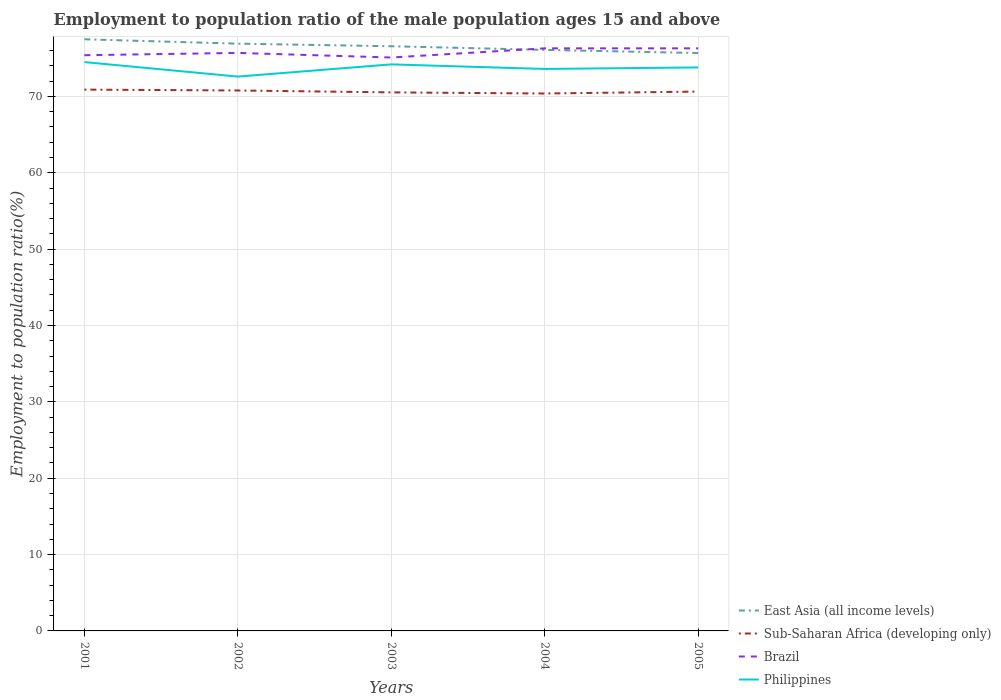Across all years, what is the maximum employment to population ratio in East Asia (all income levels)?
Your answer should be very brief. 75.69. What is the total employment to population ratio in Brazil in the graph?
Your answer should be very brief. -0.9. What is the difference between the highest and the second highest employment to population ratio in Philippines?
Provide a succinct answer. 1.9. Is the employment to population ratio in Sub-Saharan Africa (developing only) strictly greater than the employment to population ratio in Brazil over the years?
Your answer should be compact. Yes. Are the values on the major ticks of Y-axis written in scientific E-notation?
Your answer should be very brief. No. Does the graph contain any zero values?
Provide a succinct answer. No. Does the graph contain grids?
Ensure brevity in your answer.  Yes. What is the title of the graph?
Your answer should be very brief. Employment to population ratio of the male population ages 15 and above. What is the label or title of the Y-axis?
Your response must be concise. Employment to population ratio(%). What is the Employment to population ratio(%) of East Asia (all income levels) in 2001?
Provide a succinct answer. 77.49. What is the Employment to population ratio(%) in Sub-Saharan Africa (developing only) in 2001?
Provide a succinct answer. 70.89. What is the Employment to population ratio(%) in Brazil in 2001?
Provide a succinct answer. 75.4. What is the Employment to population ratio(%) in Philippines in 2001?
Provide a short and direct response. 74.5. What is the Employment to population ratio(%) in East Asia (all income levels) in 2002?
Make the answer very short. 76.91. What is the Employment to population ratio(%) of Sub-Saharan Africa (developing only) in 2002?
Provide a succinct answer. 70.78. What is the Employment to population ratio(%) in Brazil in 2002?
Your answer should be compact. 75.7. What is the Employment to population ratio(%) of Philippines in 2002?
Offer a very short reply. 72.6. What is the Employment to population ratio(%) in East Asia (all income levels) in 2003?
Provide a succinct answer. 76.58. What is the Employment to population ratio(%) in Sub-Saharan Africa (developing only) in 2003?
Provide a succinct answer. 70.53. What is the Employment to population ratio(%) of Brazil in 2003?
Provide a succinct answer. 75.1. What is the Employment to population ratio(%) of Philippines in 2003?
Keep it short and to the point. 74.2. What is the Employment to population ratio(%) in East Asia (all income levels) in 2004?
Offer a terse response. 76.1. What is the Employment to population ratio(%) of Sub-Saharan Africa (developing only) in 2004?
Ensure brevity in your answer.  70.38. What is the Employment to population ratio(%) of Brazil in 2004?
Offer a terse response. 76.3. What is the Employment to population ratio(%) of Philippines in 2004?
Offer a terse response. 73.6. What is the Employment to population ratio(%) in East Asia (all income levels) in 2005?
Keep it short and to the point. 75.69. What is the Employment to population ratio(%) of Sub-Saharan Africa (developing only) in 2005?
Give a very brief answer. 70.64. What is the Employment to population ratio(%) in Brazil in 2005?
Your answer should be compact. 76.3. What is the Employment to population ratio(%) in Philippines in 2005?
Provide a short and direct response. 73.8. Across all years, what is the maximum Employment to population ratio(%) of East Asia (all income levels)?
Ensure brevity in your answer.  77.49. Across all years, what is the maximum Employment to population ratio(%) in Sub-Saharan Africa (developing only)?
Provide a short and direct response. 70.89. Across all years, what is the maximum Employment to population ratio(%) in Brazil?
Offer a very short reply. 76.3. Across all years, what is the maximum Employment to population ratio(%) in Philippines?
Provide a short and direct response. 74.5. Across all years, what is the minimum Employment to population ratio(%) of East Asia (all income levels)?
Provide a succinct answer. 75.69. Across all years, what is the minimum Employment to population ratio(%) in Sub-Saharan Africa (developing only)?
Offer a very short reply. 70.38. Across all years, what is the minimum Employment to population ratio(%) of Brazil?
Make the answer very short. 75.1. Across all years, what is the minimum Employment to population ratio(%) of Philippines?
Make the answer very short. 72.6. What is the total Employment to population ratio(%) in East Asia (all income levels) in the graph?
Give a very brief answer. 382.76. What is the total Employment to population ratio(%) of Sub-Saharan Africa (developing only) in the graph?
Provide a succinct answer. 353.23. What is the total Employment to population ratio(%) in Brazil in the graph?
Provide a short and direct response. 378.8. What is the total Employment to population ratio(%) of Philippines in the graph?
Offer a terse response. 368.7. What is the difference between the Employment to population ratio(%) of East Asia (all income levels) in 2001 and that in 2002?
Give a very brief answer. 0.57. What is the difference between the Employment to population ratio(%) of Sub-Saharan Africa (developing only) in 2001 and that in 2002?
Provide a succinct answer. 0.11. What is the difference between the Employment to population ratio(%) in East Asia (all income levels) in 2001 and that in 2003?
Your response must be concise. 0.91. What is the difference between the Employment to population ratio(%) in Sub-Saharan Africa (developing only) in 2001 and that in 2003?
Offer a very short reply. 0.36. What is the difference between the Employment to population ratio(%) in Brazil in 2001 and that in 2003?
Your answer should be very brief. 0.3. What is the difference between the Employment to population ratio(%) in East Asia (all income levels) in 2001 and that in 2004?
Offer a terse response. 1.39. What is the difference between the Employment to population ratio(%) of Sub-Saharan Africa (developing only) in 2001 and that in 2004?
Your answer should be very brief. 0.51. What is the difference between the Employment to population ratio(%) of Brazil in 2001 and that in 2004?
Keep it short and to the point. -0.9. What is the difference between the Employment to population ratio(%) in East Asia (all income levels) in 2001 and that in 2005?
Your answer should be compact. 1.8. What is the difference between the Employment to population ratio(%) in Sub-Saharan Africa (developing only) in 2001 and that in 2005?
Offer a very short reply. 0.26. What is the difference between the Employment to population ratio(%) in Philippines in 2001 and that in 2005?
Ensure brevity in your answer.  0.7. What is the difference between the Employment to population ratio(%) of East Asia (all income levels) in 2002 and that in 2003?
Ensure brevity in your answer.  0.34. What is the difference between the Employment to population ratio(%) in Sub-Saharan Africa (developing only) in 2002 and that in 2003?
Give a very brief answer. 0.25. What is the difference between the Employment to population ratio(%) of East Asia (all income levels) in 2002 and that in 2004?
Make the answer very short. 0.81. What is the difference between the Employment to population ratio(%) of Sub-Saharan Africa (developing only) in 2002 and that in 2004?
Give a very brief answer. 0.4. What is the difference between the Employment to population ratio(%) of Brazil in 2002 and that in 2004?
Offer a terse response. -0.6. What is the difference between the Employment to population ratio(%) in East Asia (all income levels) in 2002 and that in 2005?
Make the answer very short. 1.23. What is the difference between the Employment to population ratio(%) of Sub-Saharan Africa (developing only) in 2002 and that in 2005?
Give a very brief answer. 0.14. What is the difference between the Employment to population ratio(%) of Brazil in 2002 and that in 2005?
Offer a terse response. -0.6. What is the difference between the Employment to population ratio(%) of Philippines in 2002 and that in 2005?
Your answer should be compact. -1.2. What is the difference between the Employment to population ratio(%) of East Asia (all income levels) in 2003 and that in 2004?
Provide a short and direct response. 0.48. What is the difference between the Employment to population ratio(%) of Sub-Saharan Africa (developing only) in 2003 and that in 2004?
Offer a very short reply. 0.15. What is the difference between the Employment to population ratio(%) in Philippines in 2003 and that in 2004?
Your answer should be compact. 0.6. What is the difference between the Employment to population ratio(%) of East Asia (all income levels) in 2003 and that in 2005?
Your answer should be compact. 0.89. What is the difference between the Employment to population ratio(%) of Sub-Saharan Africa (developing only) in 2003 and that in 2005?
Provide a short and direct response. -0.1. What is the difference between the Employment to population ratio(%) of Philippines in 2003 and that in 2005?
Your answer should be very brief. 0.4. What is the difference between the Employment to population ratio(%) in East Asia (all income levels) in 2004 and that in 2005?
Offer a very short reply. 0.41. What is the difference between the Employment to population ratio(%) in Sub-Saharan Africa (developing only) in 2004 and that in 2005?
Offer a terse response. -0.25. What is the difference between the Employment to population ratio(%) of Brazil in 2004 and that in 2005?
Provide a succinct answer. 0. What is the difference between the Employment to population ratio(%) in East Asia (all income levels) in 2001 and the Employment to population ratio(%) in Sub-Saharan Africa (developing only) in 2002?
Your answer should be very brief. 6.7. What is the difference between the Employment to population ratio(%) in East Asia (all income levels) in 2001 and the Employment to population ratio(%) in Brazil in 2002?
Provide a succinct answer. 1.79. What is the difference between the Employment to population ratio(%) of East Asia (all income levels) in 2001 and the Employment to population ratio(%) of Philippines in 2002?
Provide a succinct answer. 4.89. What is the difference between the Employment to population ratio(%) of Sub-Saharan Africa (developing only) in 2001 and the Employment to population ratio(%) of Brazil in 2002?
Provide a succinct answer. -4.81. What is the difference between the Employment to population ratio(%) in Sub-Saharan Africa (developing only) in 2001 and the Employment to population ratio(%) in Philippines in 2002?
Make the answer very short. -1.71. What is the difference between the Employment to population ratio(%) of Brazil in 2001 and the Employment to population ratio(%) of Philippines in 2002?
Your answer should be very brief. 2.8. What is the difference between the Employment to population ratio(%) in East Asia (all income levels) in 2001 and the Employment to population ratio(%) in Sub-Saharan Africa (developing only) in 2003?
Your answer should be compact. 6.95. What is the difference between the Employment to population ratio(%) of East Asia (all income levels) in 2001 and the Employment to population ratio(%) of Brazil in 2003?
Your answer should be compact. 2.39. What is the difference between the Employment to population ratio(%) in East Asia (all income levels) in 2001 and the Employment to population ratio(%) in Philippines in 2003?
Provide a short and direct response. 3.29. What is the difference between the Employment to population ratio(%) of Sub-Saharan Africa (developing only) in 2001 and the Employment to population ratio(%) of Brazil in 2003?
Provide a succinct answer. -4.21. What is the difference between the Employment to population ratio(%) of Sub-Saharan Africa (developing only) in 2001 and the Employment to population ratio(%) of Philippines in 2003?
Offer a very short reply. -3.31. What is the difference between the Employment to population ratio(%) in Brazil in 2001 and the Employment to population ratio(%) in Philippines in 2003?
Make the answer very short. 1.2. What is the difference between the Employment to population ratio(%) in East Asia (all income levels) in 2001 and the Employment to population ratio(%) in Sub-Saharan Africa (developing only) in 2004?
Offer a terse response. 7.1. What is the difference between the Employment to population ratio(%) of East Asia (all income levels) in 2001 and the Employment to population ratio(%) of Brazil in 2004?
Make the answer very short. 1.19. What is the difference between the Employment to population ratio(%) of East Asia (all income levels) in 2001 and the Employment to population ratio(%) of Philippines in 2004?
Make the answer very short. 3.89. What is the difference between the Employment to population ratio(%) of Sub-Saharan Africa (developing only) in 2001 and the Employment to population ratio(%) of Brazil in 2004?
Offer a very short reply. -5.41. What is the difference between the Employment to population ratio(%) in Sub-Saharan Africa (developing only) in 2001 and the Employment to population ratio(%) in Philippines in 2004?
Offer a very short reply. -2.71. What is the difference between the Employment to population ratio(%) in Brazil in 2001 and the Employment to population ratio(%) in Philippines in 2004?
Provide a short and direct response. 1.8. What is the difference between the Employment to population ratio(%) in East Asia (all income levels) in 2001 and the Employment to population ratio(%) in Sub-Saharan Africa (developing only) in 2005?
Keep it short and to the point. 6.85. What is the difference between the Employment to population ratio(%) in East Asia (all income levels) in 2001 and the Employment to population ratio(%) in Brazil in 2005?
Ensure brevity in your answer.  1.19. What is the difference between the Employment to population ratio(%) in East Asia (all income levels) in 2001 and the Employment to population ratio(%) in Philippines in 2005?
Your response must be concise. 3.69. What is the difference between the Employment to population ratio(%) in Sub-Saharan Africa (developing only) in 2001 and the Employment to population ratio(%) in Brazil in 2005?
Offer a terse response. -5.41. What is the difference between the Employment to population ratio(%) of Sub-Saharan Africa (developing only) in 2001 and the Employment to population ratio(%) of Philippines in 2005?
Ensure brevity in your answer.  -2.91. What is the difference between the Employment to population ratio(%) of East Asia (all income levels) in 2002 and the Employment to population ratio(%) of Sub-Saharan Africa (developing only) in 2003?
Make the answer very short. 6.38. What is the difference between the Employment to population ratio(%) of East Asia (all income levels) in 2002 and the Employment to population ratio(%) of Brazil in 2003?
Ensure brevity in your answer.  1.81. What is the difference between the Employment to population ratio(%) in East Asia (all income levels) in 2002 and the Employment to population ratio(%) in Philippines in 2003?
Offer a terse response. 2.71. What is the difference between the Employment to population ratio(%) of Sub-Saharan Africa (developing only) in 2002 and the Employment to population ratio(%) of Brazil in 2003?
Provide a succinct answer. -4.32. What is the difference between the Employment to population ratio(%) of Sub-Saharan Africa (developing only) in 2002 and the Employment to population ratio(%) of Philippines in 2003?
Offer a terse response. -3.42. What is the difference between the Employment to population ratio(%) in East Asia (all income levels) in 2002 and the Employment to population ratio(%) in Sub-Saharan Africa (developing only) in 2004?
Your answer should be compact. 6.53. What is the difference between the Employment to population ratio(%) of East Asia (all income levels) in 2002 and the Employment to population ratio(%) of Brazil in 2004?
Give a very brief answer. 0.61. What is the difference between the Employment to population ratio(%) in East Asia (all income levels) in 2002 and the Employment to population ratio(%) in Philippines in 2004?
Offer a very short reply. 3.31. What is the difference between the Employment to population ratio(%) of Sub-Saharan Africa (developing only) in 2002 and the Employment to population ratio(%) of Brazil in 2004?
Give a very brief answer. -5.52. What is the difference between the Employment to population ratio(%) of Sub-Saharan Africa (developing only) in 2002 and the Employment to population ratio(%) of Philippines in 2004?
Provide a succinct answer. -2.82. What is the difference between the Employment to population ratio(%) of Brazil in 2002 and the Employment to population ratio(%) of Philippines in 2004?
Offer a terse response. 2.1. What is the difference between the Employment to population ratio(%) of East Asia (all income levels) in 2002 and the Employment to population ratio(%) of Sub-Saharan Africa (developing only) in 2005?
Keep it short and to the point. 6.27. What is the difference between the Employment to population ratio(%) of East Asia (all income levels) in 2002 and the Employment to population ratio(%) of Brazil in 2005?
Make the answer very short. 0.61. What is the difference between the Employment to population ratio(%) in East Asia (all income levels) in 2002 and the Employment to population ratio(%) in Philippines in 2005?
Your answer should be very brief. 3.11. What is the difference between the Employment to population ratio(%) in Sub-Saharan Africa (developing only) in 2002 and the Employment to population ratio(%) in Brazil in 2005?
Provide a short and direct response. -5.52. What is the difference between the Employment to population ratio(%) in Sub-Saharan Africa (developing only) in 2002 and the Employment to population ratio(%) in Philippines in 2005?
Make the answer very short. -3.02. What is the difference between the Employment to population ratio(%) in Brazil in 2002 and the Employment to population ratio(%) in Philippines in 2005?
Your answer should be compact. 1.9. What is the difference between the Employment to population ratio(%) of East Asia (all income levels) in 2003 and the Employment to population ratio(%) of Sub-Saharan Africa (developing only) in 2004?
Provide a short and direct response. 6.19. What is the difference between the Employment to population ratio(%) in East Asia (all income levels) in 2003 and the Employment to population ratio(%) in Brazil in 2004?
Your answer should be very brief. 0.28. What is the difference between the Employment to population ratio(%) in East Asia (all income levels) in 2003 and the Employment to population ratio(%) in Philippines in 2004?
Offer a very short reply. 2.98. What is the difference between the Employment to population ratio(%) of Sub-Saharan Africa (developing only) in 2003 and the Employment to population ratio(%) of Brazil in 2004?
Give a very brief answer. -5.77. What is the difference between the Employment to population ratio(%) of Sub-Saharan Africa (developing only) in 2003 and the Employment to population ratio(%) of Philippines in 2004?
Keep it short and to the point. -3.07. What is the difference between the Employment to population ratio(%) in Brazil in 2003 and the Employment to population ratio(%) in Philippines in 2004?
Your answer should be compact. 1.5. What is the difference between the Employment to population ratio(%) of East Asia (all income levels) in 2003 and the Employment to population ratio(%) of Sub-Saharan Africa (developing only) in 2005?
Ensure brevity in your answer.  5.94. What is the difference between the Employment to population ratio(%) in East Asia (all income levels) in 2003 and the Employment to population ratio(%) in Brazil in 2005?
Your response must be concise. 0.28. What is the difference between the Employment to population ratio(%) in East Asia (all income levels) in 2003 and the Employment to population ratio(%) in Philippines in 2005?
Give a very brief answer. 2.78. What is the difference between the Employment to population ratio(%) in Sub-Saharan Africa (developing only) in 2003 and the Employment to population ratio(%) in Brazil in 2005?
Provide a short and direct response. -5.77. What is the difference between the Employment to population ratio(%) in Sub-Saharan Africa (developing only) in 2003 and the Employment to population ratio(%) in Philippines in 2005?
Give a very brief answer. -3.27. What is the difference between the Employment to population ratio(%) in Brazil in 2003 and the Employment to population ratio(%) in Philippines in 2005?
Provide a succinct answer. 1.3. What is the difference between the Employment to population ratio(%) in East Asia (all income levels) in 2004 and the Employment to population ratio(%) in Sub-Saharan Africa (developing only) in 2005?
Provide a succinct answer. 5.46. What is the difference between the Employment to population ratio(%) in East Asia (all income levels) in 2004 and the Employment to population ratio(%) in Brazil in 2005?
Your answer should be compact. -0.2. What is the difference between the Employment to population ratio(%) of East Asia (all income levels) in 2004 and the Employment to population ratio(%) of Philippines in 2005?
Your answer should be compact. 2.3. What is the difference between the Employment to population ratio(%) of Sub-Saharan Africa (developing only) in 2004 and the Employment to population ratio(%) of Brazil in 2005?
Give a very brief answer. -5.92. What is the difference between the Employment to population ratio(%) of Sub-Saharan Africa (developing only) in 2004 and the Employment to population ratio(%) of Philippines in 2005?
Provide a succinct answer. -3.42. What is the difference between the Employment to population ratio(%) in Brazil in 2004 and the Employment to population ratio(%) in Philippines in 2005?
Your answer should be compact. 2.5. What is the average Employment to population ratio(%) in East Asia (all income levels) per year?
Your answer should be compact. 76.55. What is the average Employment to population ratio(%) of Sub-Saharan Africa (developing only) per year?
Ensure brevity in your answer.  70.65. What is the average Employment to population ratio(%) in Brazil per year?
Provide a succinct answer. 75.76. What is the average Employment to population ratio(%) in Philippines per year?
Provide a short and direct response. 73.74. In the year 2001, what is the difference between the Employment to population ratio(%) of East Asia (all income levels) and Employment to population ratio(%) of Sub-Saharan Africa (developing only)?
Provide a succinct answer. 6.59. In the year 2001, what is the difference between the Employment to population ratio(%) of East Asia (all income levels) and Employment to population ratio(%) of Brazil?
Provide a short and direct response. 2.09. In the year 2001, what is the difference between the Employment to population ratio(%) in East Asia (all income levels) and Employment to population ratio(%) in Philippines?
Provide a succinct answer. 2.99. In the year 2001, what is the difference between the Employment to population ratio(%) in Sub-Saharan Africa (developing only) and Employment to population ratio(%) in Brazil?
Ensure brevity in your answer.  -4.51. In the year 2001, what is the difference between the Employment to population ratio(%) of Sub-Saharan Africa (developing only) and Employment to population ratio(%) of Philippines?
Provide a short and direct response. -3.61. In the year 2001, what is the difference between the Employment to population ratio(%) of Brazil and Employment to population ratio(%) of Philippines?
Provide a short and direct response. 0.9. In the year 2002, what is the difference between the Employment to population ratio(%) in East Asia (all income levels) and Employment to population ratio(%) in Sub-Saharan Africa (developing only)?
Give a very brief answer. 6.13. In the year 2002, what is the difference between the Employment to population ratio(%) of East Asia (all income levels) and Employment to population ratio(%) of Brazil?
Provide a short and direct response. 1.21. In the year 2002, what is the difference between the Employment to population ratio(%) of East Asia (all income levels) and Employment to population ratio(%) of Philippines?
Provide a short and direct response. 4.31. In the year 2002, what is the difference between the Employment to population ratio(%) in Sub-Saharan Africa (developing only) and Employment to population ratio(%) in Brazil?
Your answer should be very brief. -4.92. In the year 2002, what is the difference between the Employment to population ratio(%) in Sub-Saharan Africa (developing only) and Employment to population ratio(%) in Philippines?
Your response must be concise. -1.82. In the year 2002, what is the difference between the Employment to population ratio(%) of Brazil and Employment to population ratio(%) of Philippines?
Offer a terse response. 3.1. In the year 2003, what is the difference between the Employment to population ratio(%) in East Asia (all income levels) and Employment to population ratio(%) in Sub-Saharan Africa (developing only)?
Keep it short and to the point. 6.04. In the year 2003, what is the difference between the Employment to population ratio(%) of East Asia (all income levels) and Employment to population ratio(%) of Brazil?
Give a very brief answer. 1.48. In the year 2003, what is the difference between the Employment to population ratio(%) of East Asia (all income levels) and Employment to population ratio(%) of Philippines?
Your response must be concise. 2.38. In the year 2003, what is the difference between the Employment to population ratio(%) of Sub-Saharan Africa (developing only) and Employment to population ratio(%) of Brazil?
Keep it short and to the point. -4.57. In the year 2003, what is the difference between the Employment to population ratio(%) in Sub-Saharan Africa (developing only) and Employment to population ratio(%) in Philippines?
Offer a very short reply. -3.67. In the year 2004, what is the difference between the Employment to population ratio(%) of East Asia (all income levels) and Employment to population ratio(%) of Sub-Saharan Africa (developing only)?
Make the answer very short. 5.71. In the year 2004, what is the difference between the Employment to population ratio(%) of East Asia (all income levels) and Employment to population ratio(%) of Brazil?
Provide a short and direct response. -0.2. In the year 2004, what is the difference between the Employment to population ratio(%) of East Asia (all income levels) and Employment to population ratio(%) of Philippines?
Offer a terse response. 2.5. In the year 2004, what is the difference between the Employment to population ratio(%) of Sub-Saharan Africa (developing only) and Employment to population ratio(%) of Brazil?
Provide a succinct answer. -5.92. In the year 2004, what is the difference between the Employment to population ratio(%) in Sub-Saharan Africa (developing only) and Employment to population ratio(%) in Philippines?
Give a very brief answer. -3.22. In the year 2004, what is the difference between the Employment to population ratio(%) of Brazil and Employment to population ratio(%) of Philippines?
Your response must be concise. 2.7. In the year 2005, what is the difference between the Employment to population ratio(%) in East Asia (all income levels) and Employment to population ratio(%) in Sub-Saharan Africa (developing only)?
Provide a short and direct response. 5.05. In the year 2005, what is the difference between the Employment to population ratio(%) of East Asia (all income levels) and Employment to population ratio(%) of Brazil?
Your answer should be very brief. -0.61. In the year 2005, what is the difference between the Employment to population ratio(%) in East Asia (all income levels) and Employment to population ratio(%) in Philippines?
Keep it short and to the point. 1.89. In the year 2005, what is the difference between the Employment to population ratio(%) in Sub-Saharan Africa (developing only) and Employment to population ratio(%) in Brazil?
Provide a short and direct response. -5.66. In the year 2005, what is the difference between the Employment to population ratio(%) in Sub-Saharan Africa (developing only) and Employment to population ratio(%) in Philippines?
Your answer should be compact. -3.16. In the year 2005, what is the difference between the Employment to population ratio(%) of Brazil and Employment to population ratio(%) of Philippines?
Give a very brief answer. 2.5. What is the ratio of the Employment to population ratio(%) in East Asia (all income levels) in 2001 to that in 2002?
Provide a short and direct response. 1.01. What is the ratio of the Employment to population ratio(%) of Sub-Saharan Africa (developing only) in 2001 to that in 2002?
Keep it short and to the point. 1. What is the ratio of the Employment to population ratio(%) of Brazil in 2001 to that in 2002?
Offer a terse response. 1. What is the ratio of the Employment to population ratio(%) of Philippines in 2001 to that in 2002?
Provide a succinct answer. 1.03. What is the ratio of the Employment to population ratio(%) of East Asia (all income levels) in 2001 to that in 2003?
Your answer should be very brief. 1.01. What is the ratio of the Employment to population ratio(%) in Sub-Saharan Africa (developing only) in 2001 to that in 2003?
Your answer should be very brief. 1.01. What is the ratio of the Employment to population ratio(%) of Brazil in 2001 to that in 2003?
Your response must be concise. 1. What is the ratio of the Employment to population ratio(%) of East Asia (all income levels) in 2001 to that in 2004?
Offer a terse response. 1.02. What is the ratio of the Employment to population ratio(%) in Sub-Saharan Africa (developing only) in 2001 to that in 2004?
Provide a succinct answer. 1.01. What is the ratio of the Employment to population ratio(%) of Philippines in 2001 to that in 2004?
Make the answer very short. 1.01. What is the ratio of the Employment to population ratio(%) in East Asia (all income levels) in 2001 to that in 2005?
Make the answer very short. 1.02. What is the ratio of the Employment to population ratio(%) of Sub-Saharan Africa (developing only) in 2001 to that in 2005?
Ensure brevity in your answer.  1. What is the ratio of the Employment to population ratio(%) in Brazil in 2001 to that in 2005?
Keep it short and to the point. 0.99. What is the ratio of the Employment to population ratio(%) of Philippines in 2001 to that in 2005?
Ensure brevity in your answer.  1.01. What is the ratio of the Employment to population ratio(%) of East Asia (all income levels) in 2002 to that in 2003?
Provide a succinct answer. 1. What is the ratio of the Employment to population ratio(%) in Sub-Saharan Africa (developing only) in 2002 to that in 2003?
Provide a short and direct response. 1. What is the ratio of the Employment to population ratio(%) in Philippines in 2002 to that in 2003?
Ensure brevity in your answer.  0.98. What is the ratio of the Employment to population ratio(%) of East Asia (all income levels) in 2002 to that in 2004?
Provide a short and direct response. 1.01. What is the ratio of the Employment to population ratio(%) of Philippines in 2002 to that in 2004?
Provide a short and direct response. 0.99. What is the ratio of the Employment to population ratio(%) of East Asia (all income levels) in 2002 to that in 2005?
Offer a terse response. 1.02. What is the ratio of the Employment to population ratio(%) in Brazil in 2002 to that in 2005?
Provide a short and direct response. 0.99. What is the ratio of the Employment to population ratio(%) of Philippines in 2002 to that in 2005?
Ensure brevity in your answer.  0.98. What is the ratio of the Employment to population ratio(%) of Sub-Saharan Africa (developing only) in 2003 to that in 2004?
Your answer should be compact. 1. What is the ratio of the Employment to population ratio(%) of Brazil in 2003 to that in 2004?
Your answer should be compact. 0.98. What is the ratio of the Employment to population ratio(%) of Philippines in 2003 to that in 2004?
Your answer should be compact. 1.01. What is the ratio of the Employment to population ratio(%) in East Asia (all income levels) in 2003 to that in 2005?
Provide a short and direct response. 1.01. What is the ratio of the Employment to population ratio(%) of Brazil in 2003 to that in 2005?
Your answer should be very brief. 0.98. What is the ratio of the Employment to population ratio(%) of Philippines in 2003 to that in 2005?
Your answer should be very brief. 1.01. What is the ratio of the Employment to population ratio(%) of East Asia (all income levels) in 2004 to that in 2005?
Your answer should be very brief. 1.01. What is the ratio of the Employment to population ratio(%) in Philippines in 2004 to that in 2005?
Your response must be concise. 1. What is the difference between the highest and the second highest Employment to population ratio(%) of East Asia (all income levels)?
Offer a very short reply. 0.57. What is the difference between the highest and the second highest Employment to population ratio(%) in Sub-Saharan Africa (developing only)?
Your answer should be compact. 0.11. What is the difference between the highest and the second highest Employment to population ratio(%) of Brazil?
Provide a short and direct response. 0. What is the difference between the highest and the second highest Employment to population ratio(%) of Philippines?
Your response must be concise. 0.3. What is the difference between the highest and the lowest Employment to population ratio(%) in East Asia (all income levels)?
Keep it short and to the point. 1.8. What is the difference between the highest and the lowest Employment to population ratio(%) in Sub-Saharan Africa (developing only)?
Offer a very short reply. 0.51. 